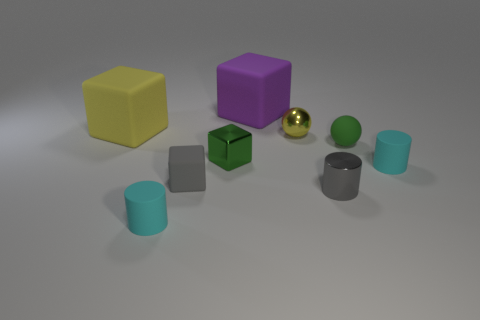What material is the tiny cylinder that is the same color as the tiny matte block? metal 